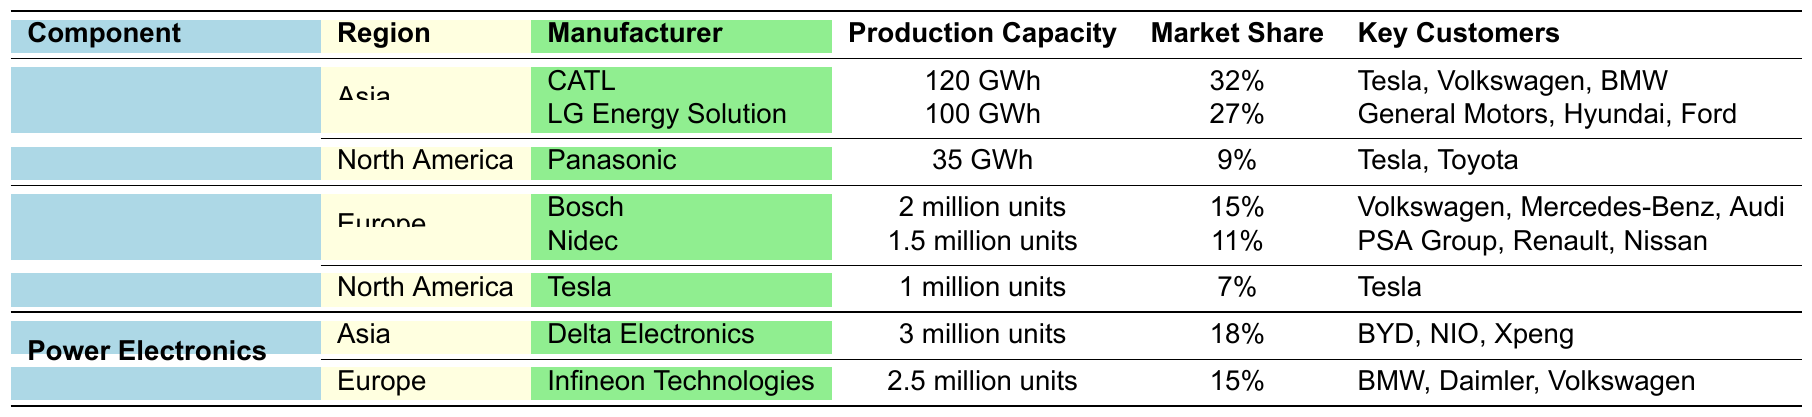What is the production capacity of CATL? CATL is listed under the Lithium-ion Batteries component in the Asia region, and its production capacity is 120 GWh as shown in the table.
Answer: 120 GWh Which manufacturer has the highest market share for Lithium-ion Batteries? Among the lithium-ion battery manufacturers listed under Asia, CATL has the highest market share at 32%, compared to LG Energy Solution's 27% and Panasonic's 9%.
Answer: CATL What is the combined production capacity of electric motor manufacturers in Europe? There are two electric motor manufacturers in Europe: Bosch with 2 million units and Nidec with 1.5 million units. Their combined production capacity is 2 + 1.5 = 3.5 million units.
Answer: 3.5 million units Is Tesla a key customer for Panasonic? The table indicates that Panasonic has key customers listed as Tesla and Toyota, so it is true.
Answer: Yes Which component has the lowest production capacity among the manufacturers listed? By reviewing the production capacities for each component, Panasonic's 35 GWh for lithium-ion batteries is lower than any electric motor or power electronics manufacturer.
Answer: 35 GWh What is the total market share of manufacturers for Power Electronics? The total market share for Power Electronics consists of Delta Electronics (18%) and Infineon Technologies (15%). Adding these gives 18 + 15 = 33%.
Answer: 33% Which region does LG Energy Solution operate in? LG Energy Solution is listed under the Lithium-ion Batteries component and operates in the Asia region, as shown in the table.
Answer: Asia Are there any manufacturers with a production capacity of over 2 million units? In the table, Bosch and Delta Electronics are the only manufacturers exceeding 2 million units in production capacity, with Bosch producing 2 million units and Delta Electronics producing 3 million units. Therefore, the answer is yes.
Answer: Yes What percentage of the market share does Tesla hold for electric motors? Tesla holds a market share of 7% for electric motors, as indicated in the table.
Answer: 7% Which manufacturer has the highest market share for Power Electronics? Delta Electronics has the highest market share for Power Electronics at 18%, compared to Infineon Technologies at 15%.
Answer: Delta Electronics 